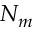<formula> <loc_0><loc_0><loc_500><loc_500>N _ { m }</formula> 